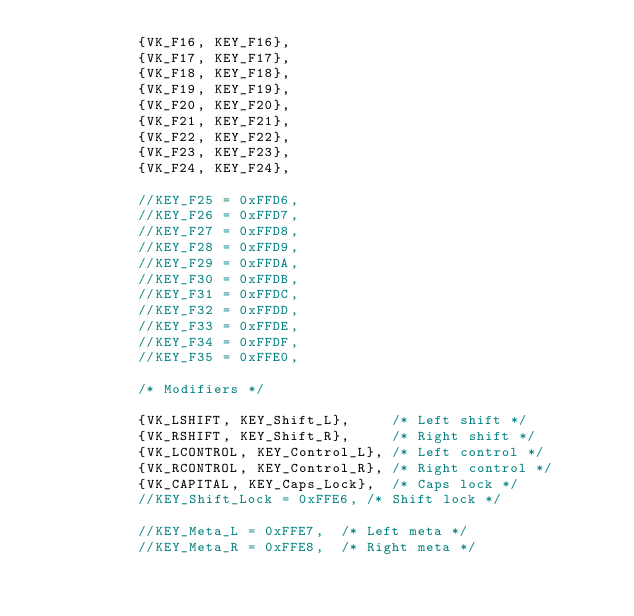<code> <loc_0><loc_0><loc_500><loc_500><_C++_>            {VK_F16, KEY_F16},
            {VK_F17, KEY_F17},
            {VK_F18, KEY_F18},
            {VK_F19, KEY_F19},
            {VK_F20, KEY_F20},
            {VK_F21, KEY_F21},
            {VK_F22, KEY_F22},
            {VK_F23, KEY_F23},
            {VK_F24, KEY_F24},

            //KEY_F25 = 0xFFD6,
            //KEY_F26 = 0xFFD7,
            //KEY_F27 = 0xFFD8,
            //KEY_F28 = 0xFFD9,
            //KEY_F29 = 0xFFDA,
            //KEY_F30 = 0xFFDB,
            //KEY_F31 = 0xFFDC,
            //KEY_F32 = 0xFFDD,
            //KEY_F33 = 0xFFDE,
            //KEY_F34 = 0xFFDF,
            //KEY_F35 = 0xFFE0,

            /* Modifiers */

            {VK_LSHIFT, KEY_Shift_L},     /* Left shift */
            {VK_RSHIFT, KEY_Shift_R},     /* Right shift */
            {VK_LCONTROL, KEY_Control_L}, /* Left control */
            {VK_RCONTROL, KEY_Control_R}, /* Right control */
            {VK_CAPITAL, KEY_Caps_Lock},  /* Caps lock */
            //KEY_Shift_Lock = 0xFFE6, /* Shift lock */

            //KEY_Meta_L = 0xFFE7,  /* Left meta */
            //KEY_Meta_R = 0xFFE8,  /* Right meta */</code> 